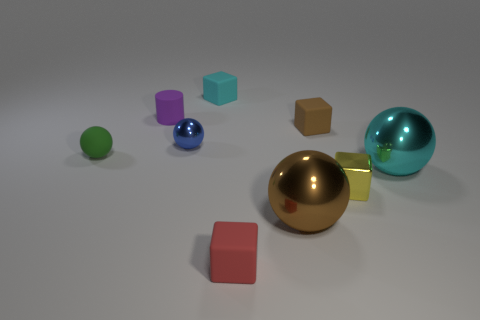Is the green thing the same size as the brown ball?
Your response must be concise. No. What is the size of the shiny sphere that is both behind the tiny yellow shiny block and on the right side of the tiny blue shiny sphere?
Provide a short and direct response. Large. Is there another object of the same shape as the tiny red thing?
Ensure brevity in your answer.  Yes. Are there any metal balls that have the same size as the red matte thing?
Make the answer very short. Yes. There is a large thing that is to the right of the tiny metallic thing in front of the cyan thing on the right side of the red cube; what color is it?
Your response must be concise. Cyan. Is the material of the tiny cyan object the same as the big object right of the tiny brown block?
Give a very brief answer. No. The cyan shiny object that is the same shape as the large brown shiny object is what size?
Offer a very short reply. Large. Is the number of small cyan matte objects on the left side of the small cyan object the same as the number of large metallic objects on the right side of the big cyan metallic object?
Your answer should be very brief. Yes. What number of other objects are the same material as the cylinder?
Provide a succinct answer. 4. Are there the same number of metallic blocks behind the tiny matte sphere and small cyan blocks?
Your response must be concise. No. 